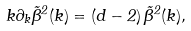Convert formula to latex. <formula><loc_0><loc_0><loc_500><loc_500>k \partial _ { k } { \tilde { \beta } } ^ { 2 } ( k ) = ( { d - 2 } ) \, { \tilde { \beta } } ^ { 2 } ( k ) ,</formula> 